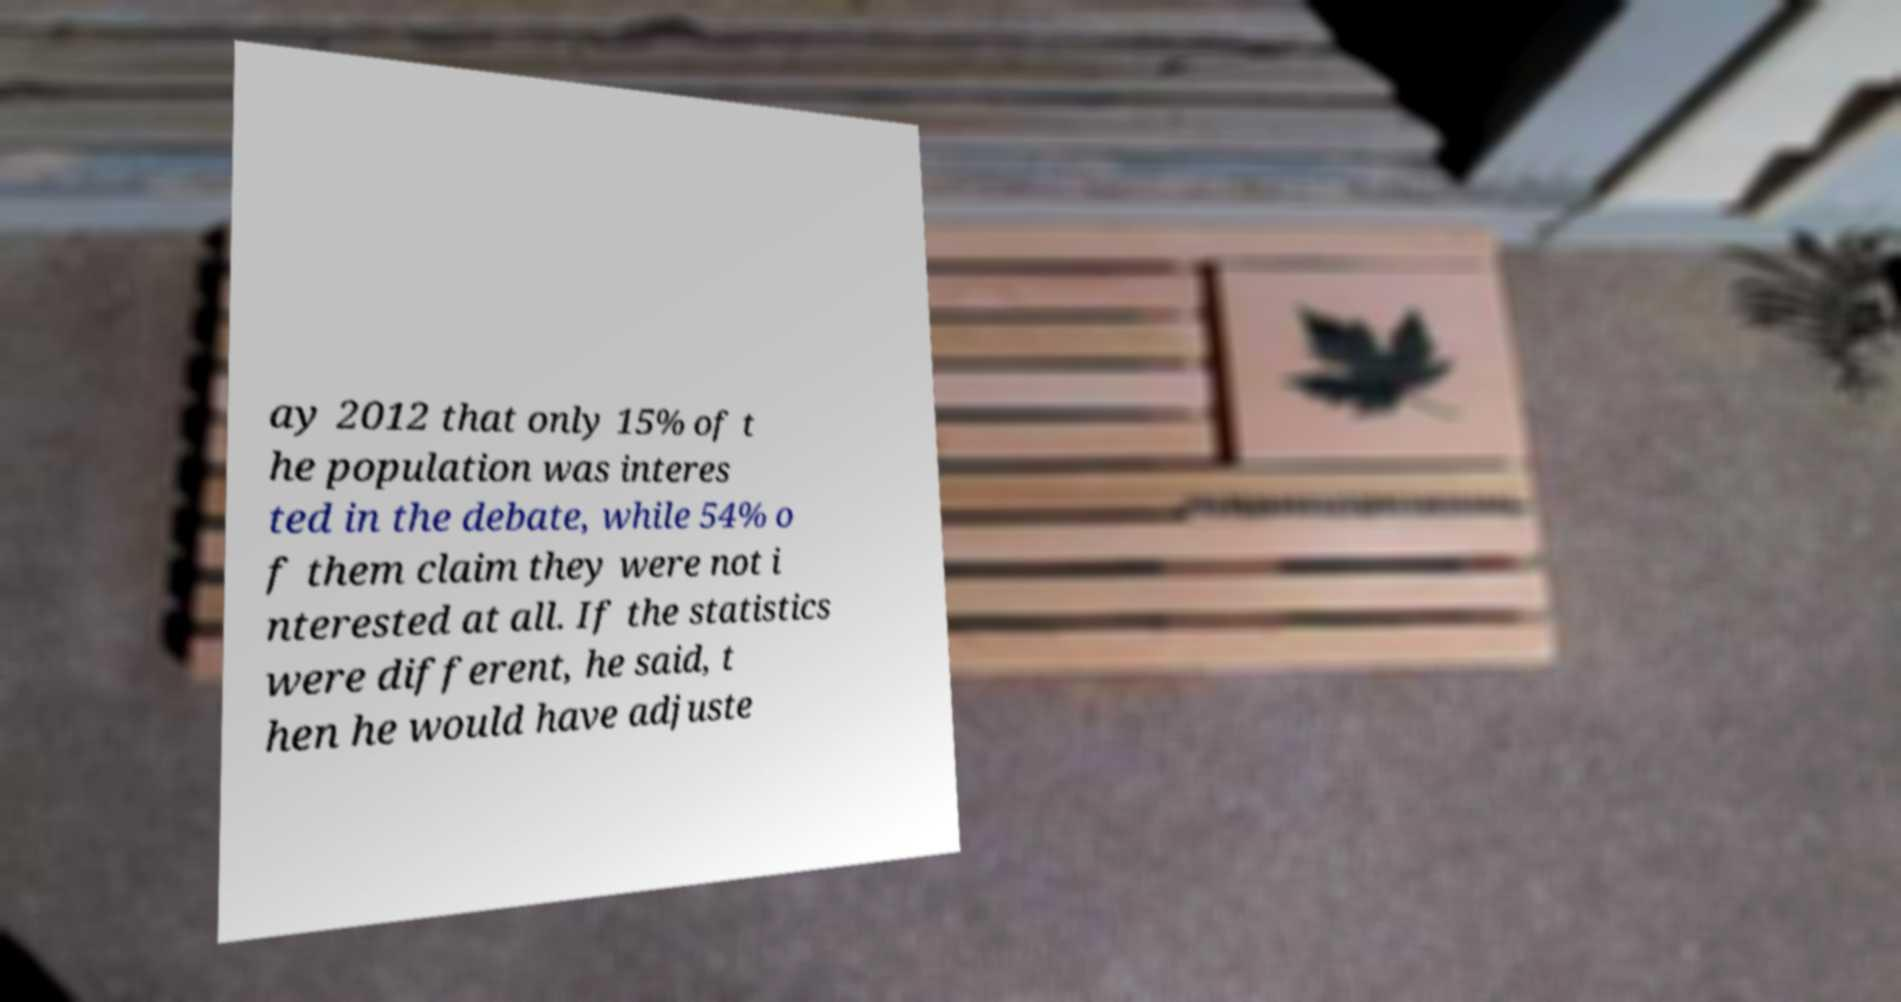Could you extract and type out the text from this image? ay 2012 that only 15% of t he population was interes ted in the debate, while 54% o f them claim they were not i nterested at all. If the statistics were different, he said, t hen he would have adjuste 